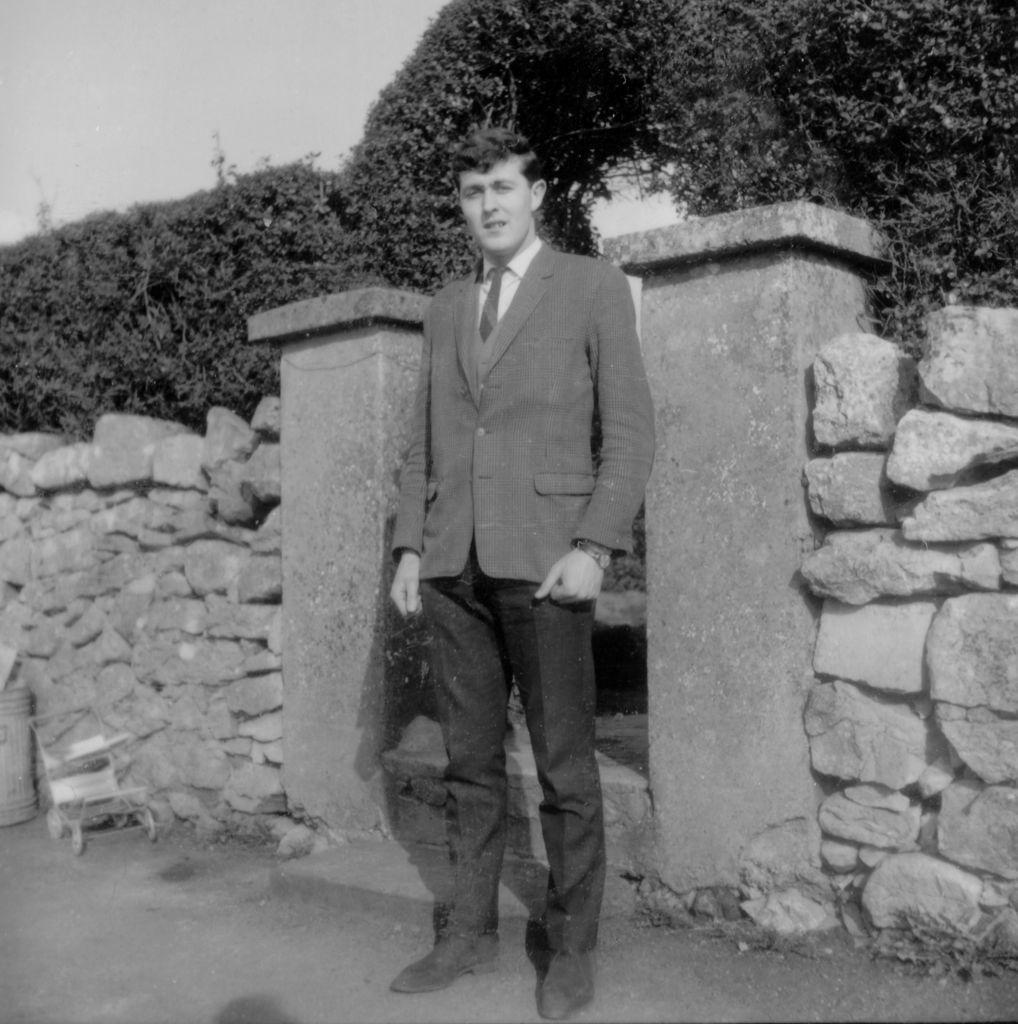In one or two sentences, can you explain what this image depicts? In this image we can see there is a person standing on the ground and there is a dustbin and a stroller. At the back there is a wall and arch with creeper plants and the sky. 